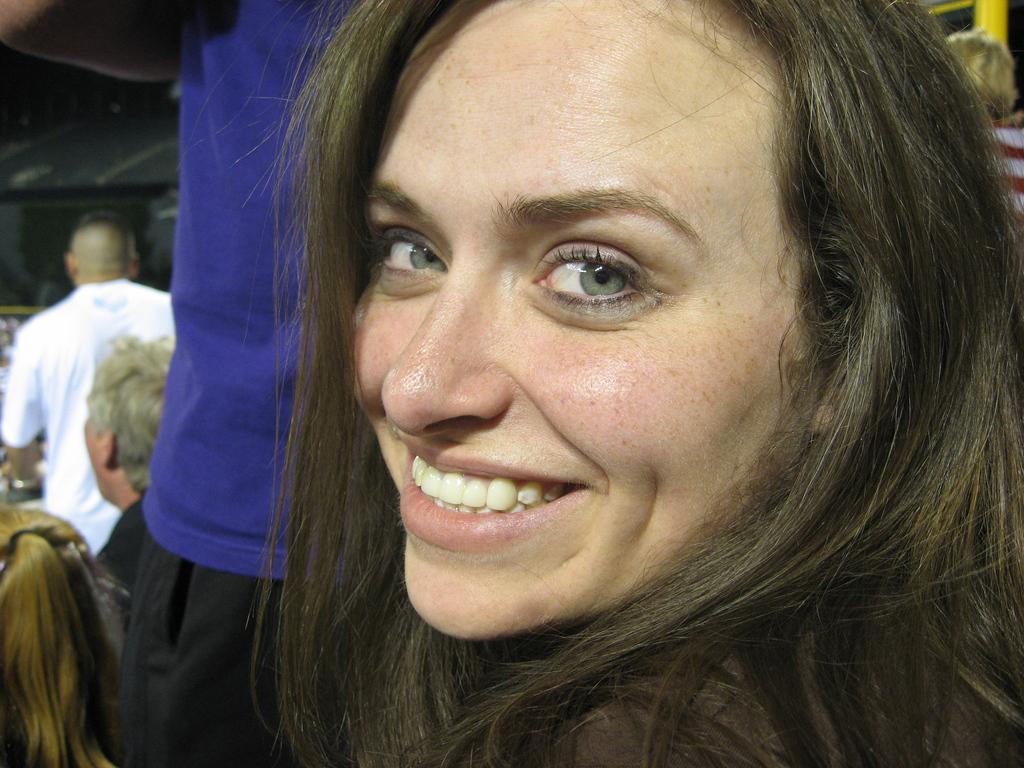Describe this image in one or two sentences. In this picture we can see a woman smiling and in the background we can see a group of people. 